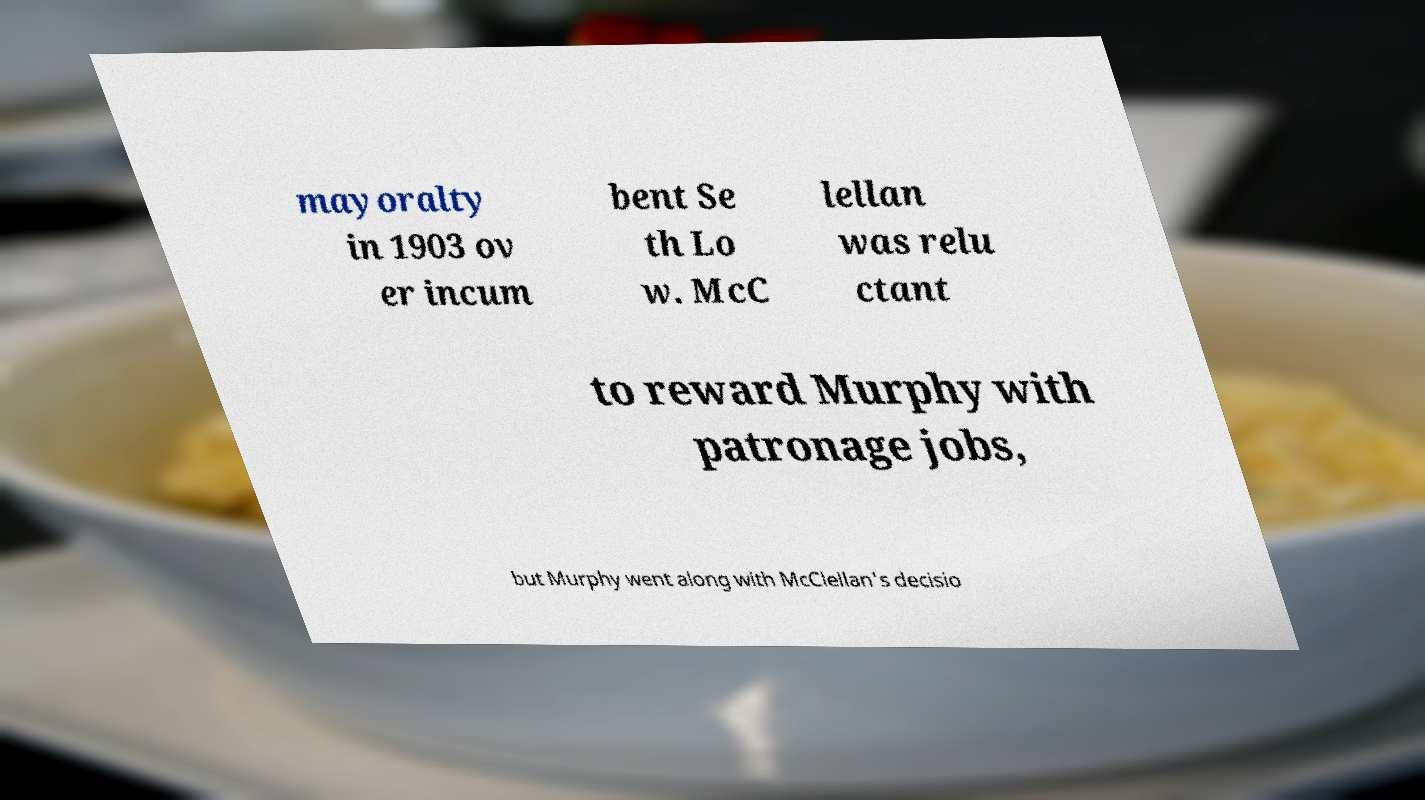There's text embedded in this image that I need extracted. Can you transcribe it verbatim? mayoralty in 1903 ov er incum bent Se th Lo w. McC lellan was relu ctant to reward Murphy with patronage jobs, but Murphy went along with McClellan's decisio 